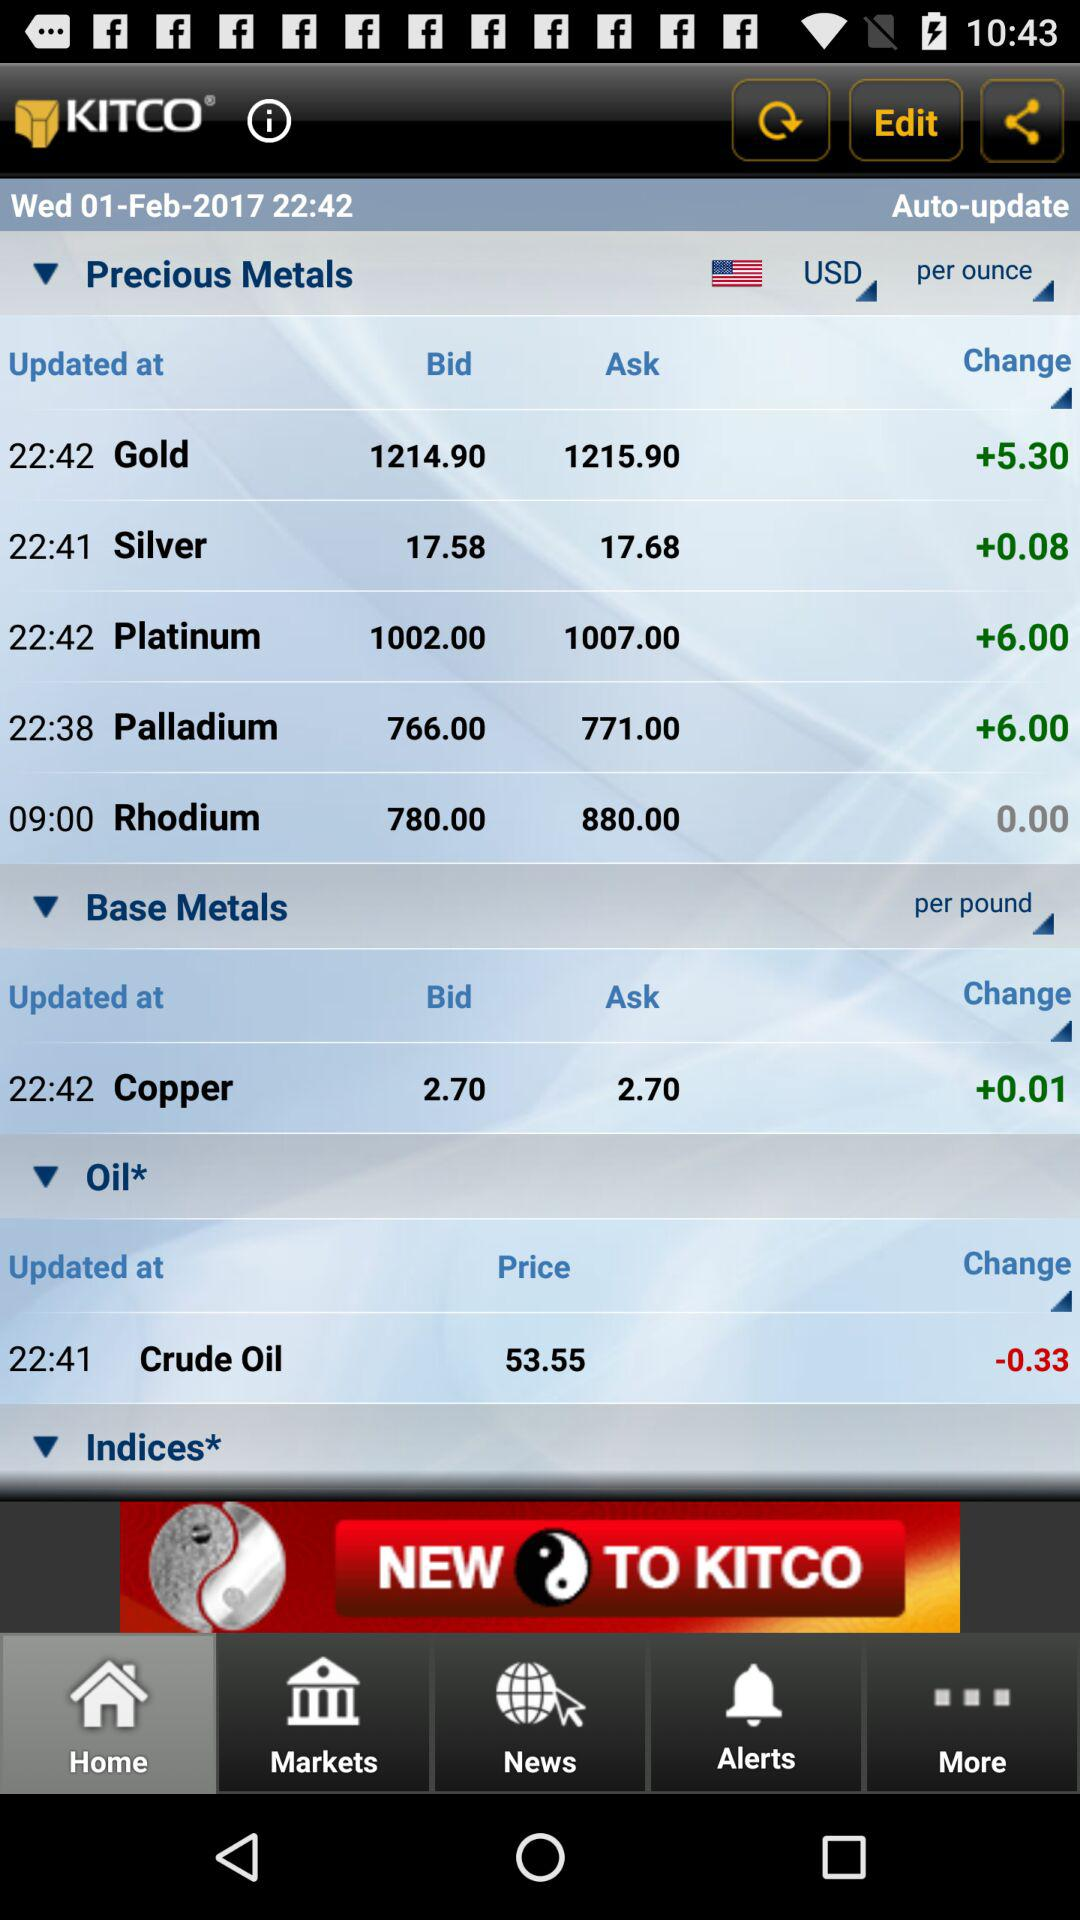What is the shown date? The shown date is Wednesday, February 1, 2017. 